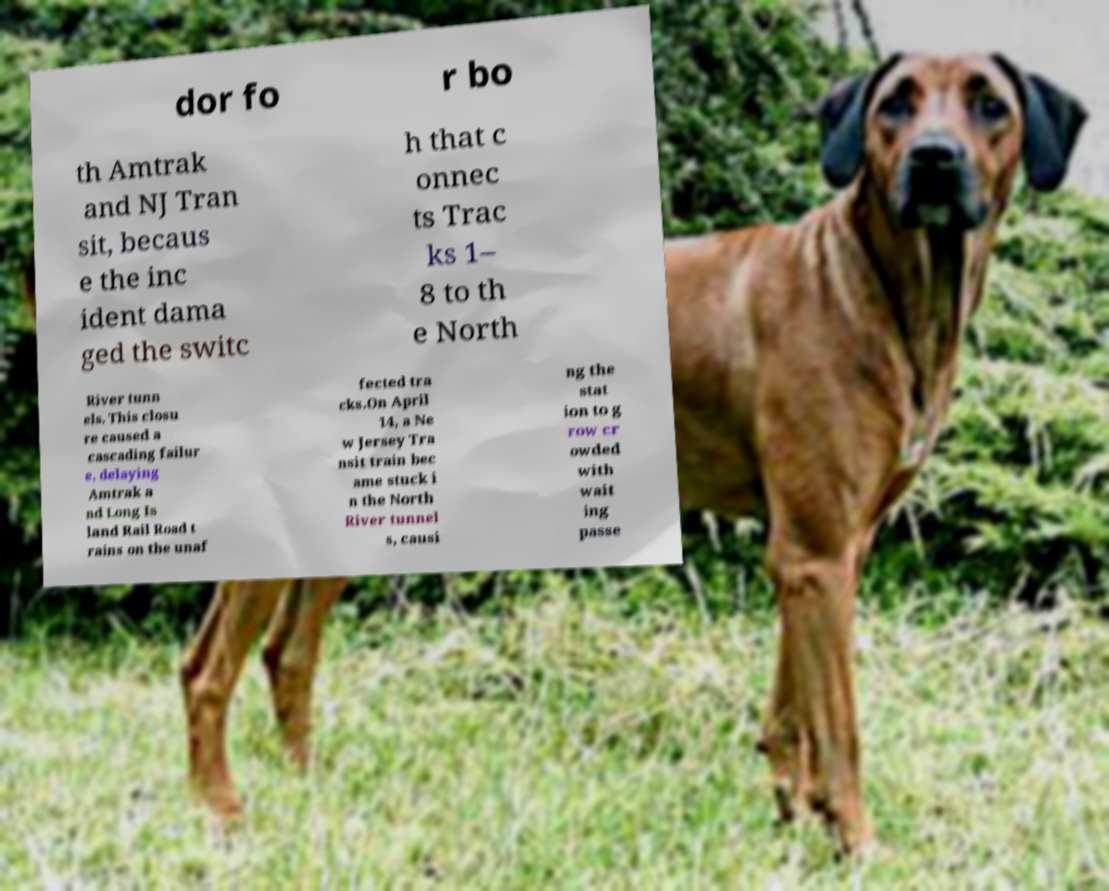Can you accurately transcribe the text from the provided image for me? dor fo r bo th Amtrak and NJ Tran sit, becaus e the inc ident dama ged the switc h that c onnec ts Trac ks 1– 8 to th e North River tunn els. This closu re caused a cascading failur e, delaying Amtrak a nd Long Is land Rail Road t rains on the unaf fected tra cks.On April 14, a Ne w Jersey Tra nsit train bec ame stuck i n the North River tunnel s, causi ng the stat ion to g row cr owded with wait ing passe 